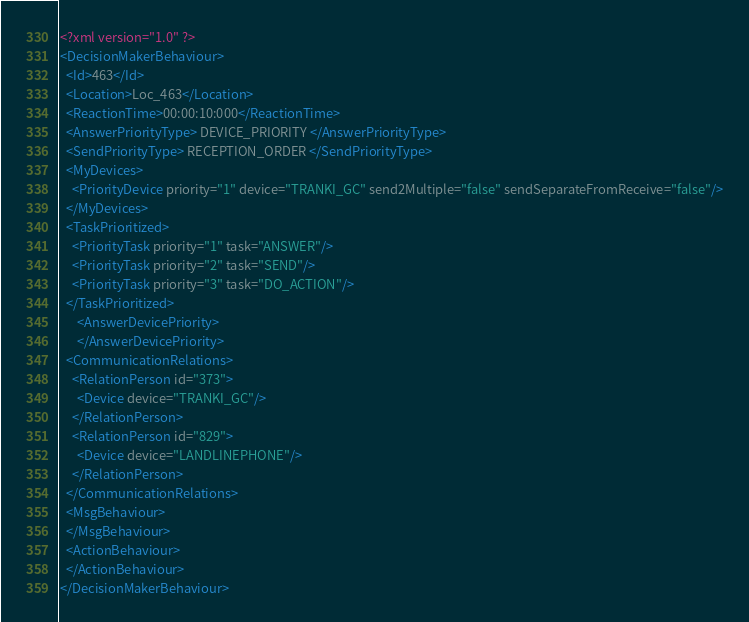Convert code to text. <code><loc_0><loc_0><loc_500><loc_500><_XML_><?xml version="1.0" ?>
<DecisionMakerBehaviour>
  <Id>463</Id>
  <Location>Loc_463</Location>
  <ReactionTime>00:00:10:000</ReactionTime>
  <AnswerPriorityType> DEVICE_PRIORITY </AnswerPriorityType>
  <SendPriorityType> RECEPTION_ORDER </SendPriorityType>
  <MyDevices>
    <PriorityDevice priority="1" device="TRANKI_GC" send2Multiple="false" sendSeparateFromReceive="false"/>
  </MyDevices>
  <TaskPrioritized>
    <PriorityTask priority="1" task="ANSWER"/>
    <PriorityTask priority="2" task="SEND"/>
    <PriorityTask priority="3" task="DO_ACTION"/>
  </TaskPrioritized>
      <AnswerDevicePriority>
      </AnswerDevicePriority>
  <CommunicationRelations>
    <RelationPerson id="373">
      <Device device="TRANKI_GC"/>
    </RelationPerson>
    <RelationPerson id="829">
      <Device device="LANDLINEPHONE"/>
    </RelationPerson>
  </CommunicationRelations>
  <MsgBehaviour>
  </MsgBehaviour>
  <ActionBehaviour>
  </ActionBehaviour>
</DecisionMakerBehaviour>
</code> 